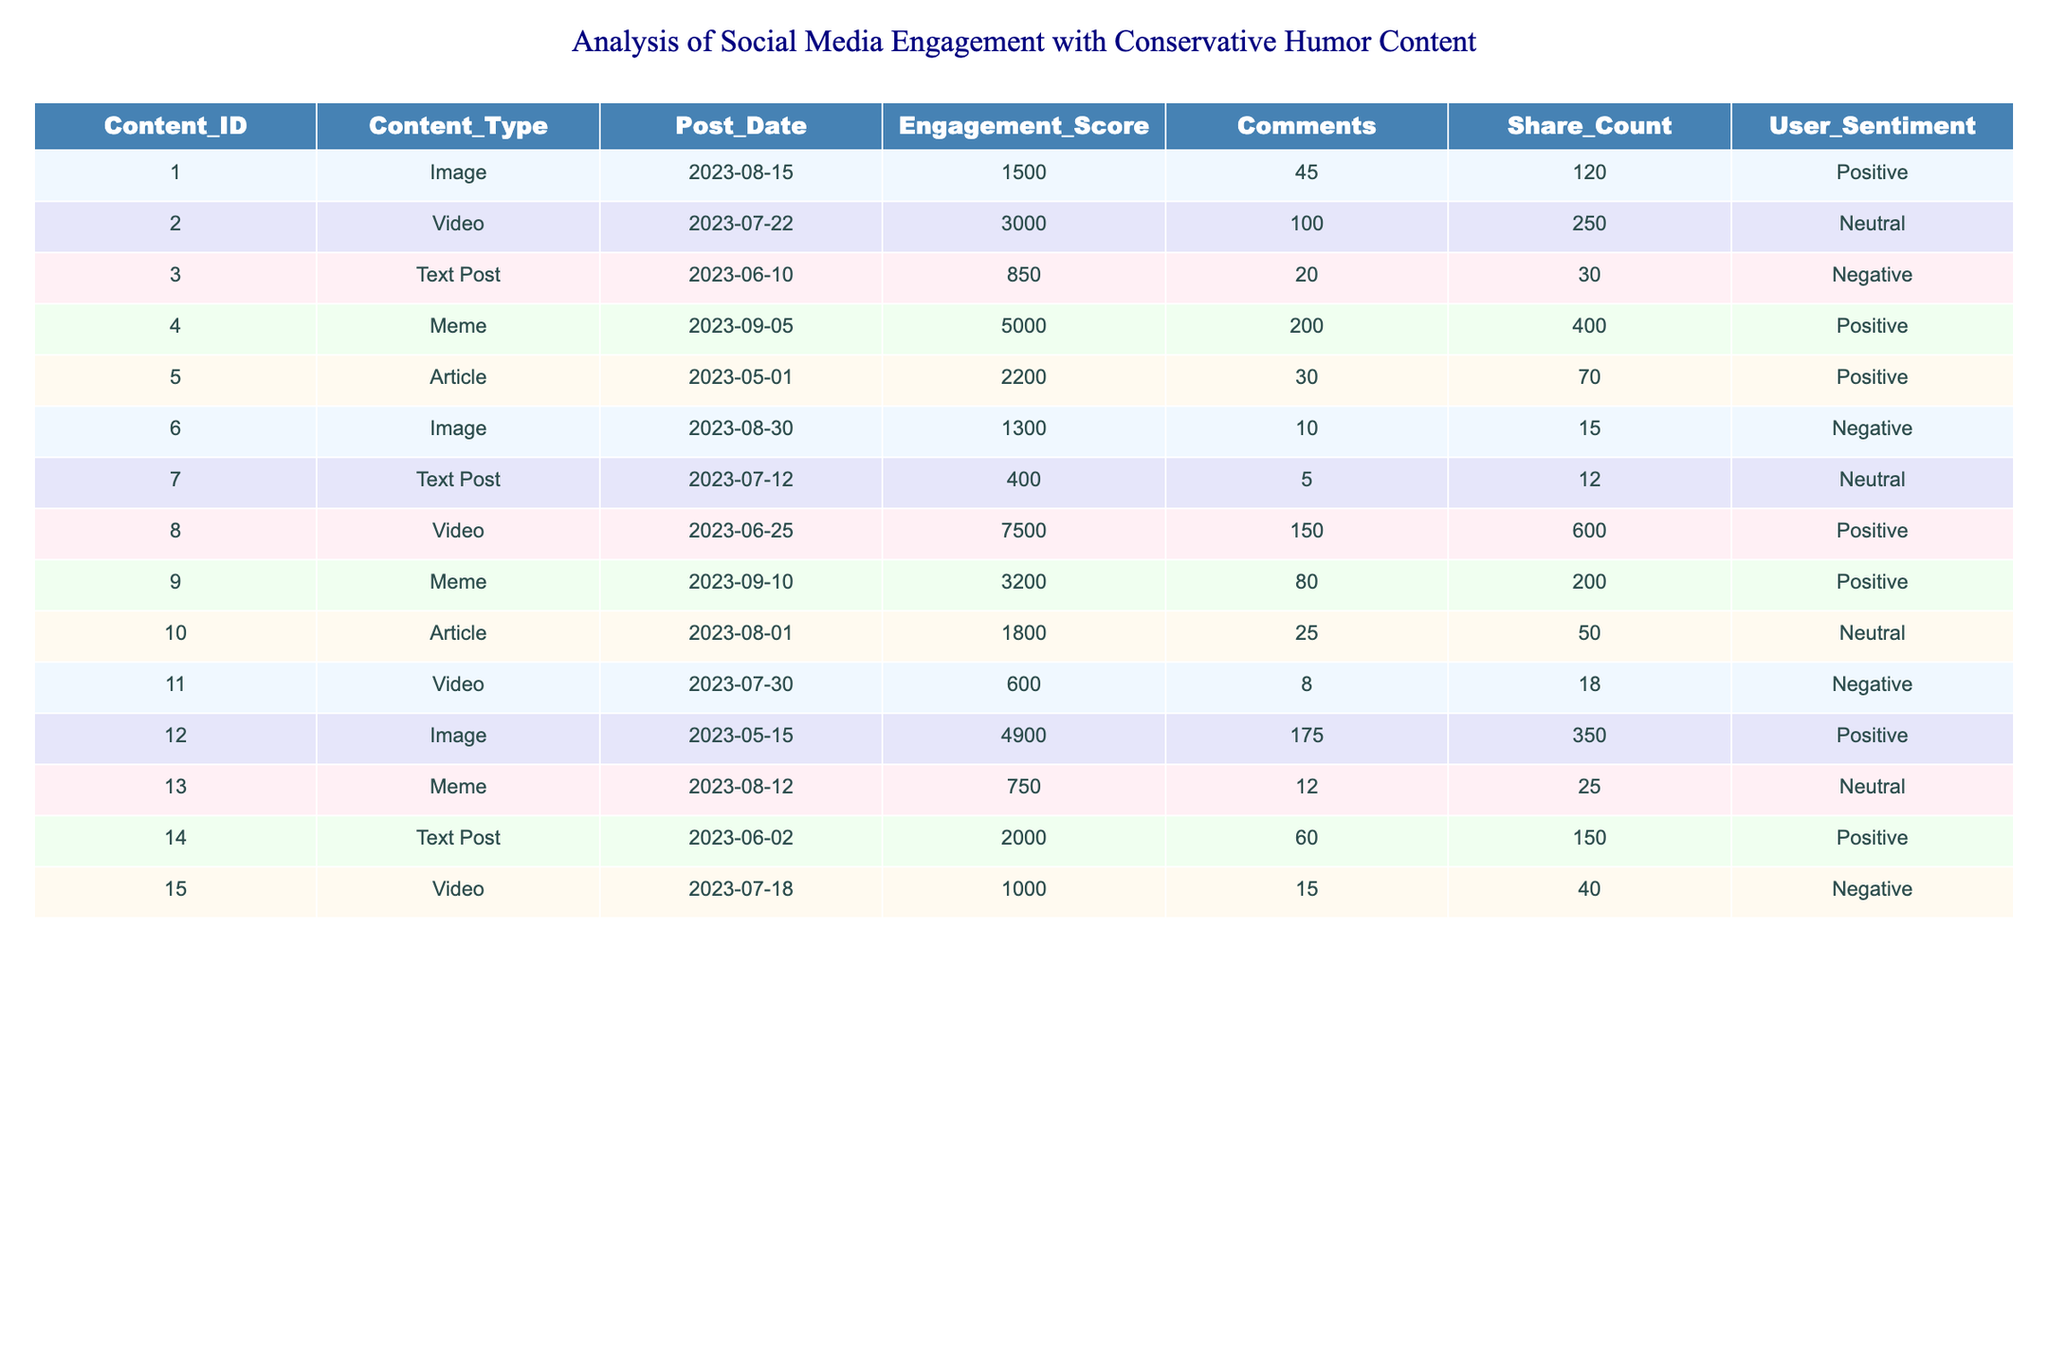What is the engagement score for the post with Content_ID 4? The engagement score can be found directly in the table under the engagement score column for Content_ID 4. The score is listed as 5000.
Answer: 5000 Which content type received the highest share count? By reviewing the share count for each content type, Content_ID 8 has the highest share count of 600.
Answer: Video What is the average engagement score for all meme posts? The engagement scores for the meme posts (Content_IDs 4, 9, and 13) are 5000, 3200, and 750 respectively. The sum is 5000 + 3200 + 750 = 8950, and there are 3 meme posts. Therefore, the average engagement score is 8950 / 3 = 2983.33.
Answer: 2983.33 How many posts have a positive user sentiment? The user sentiment column can be filtered to count the number of posts marked as positive. There are 6 such posts (Content_IDs 1, 4, 2, 8, 12, 14).
Answer: 6 What is the difference in engagement scores between the most and least engaging text posts? The engagement scores for the text posts (Content_IDs 3, 7, and 14) are 850, 400, and 2000, respectively. The highest engagement score is 2000, and the lowest is 400. The difference is 2000 - 400 = 1600.
Answer: 1600 Is there any content type that had a negative user sentiment and received more than 1000 engagement score? The negative sentiment posts (Content_IDs 3, 6, 11, and 15) are checked against their engagement scores. Content_ID 15 has an engagement score of 1000, which is not more than 1000, and Content_ID 11 has a score of 600, which is also not more than 1000. Thus, there are no such posts.
Answer: No What was the total number of comments on the posts with neutral user sentiment? The posts with neutral sentiment (Content_IDs 2, 7, 10, and 13) have the following comment counts: 100, 5, 25, and 12, respectively. The total comments are calculated by summing these values: 100 + 5 + 25 + 12 = 142.
Answer: 142 Which content type has the highest engagement score, and what is that score? Looking through the engagement scores, the highest score appears to be from the video at Content_ID 8, with a score of 7500.
Answer: Video, 7500 How many more shares did the most shared post have compared to the least shared post? The most shared post is Content_ID 8 with 600 shares, while the least shared post is Content_ID 7 with 12 shares. The difference is calculated as 600 - 12 = 588.
Answer: 588 What is the engagement score range of all posts? The engagement scores in the table are: 1500, 3000, 850, 5000, 2200, 1300, 400, 7500, 3200, 1800, 600, 4900, 750, 2000, and 1000. The maximum engagement score is 7500 and the minimum is 400. So, the range is 7500 - 400 = 7100.
Answer: 7100 